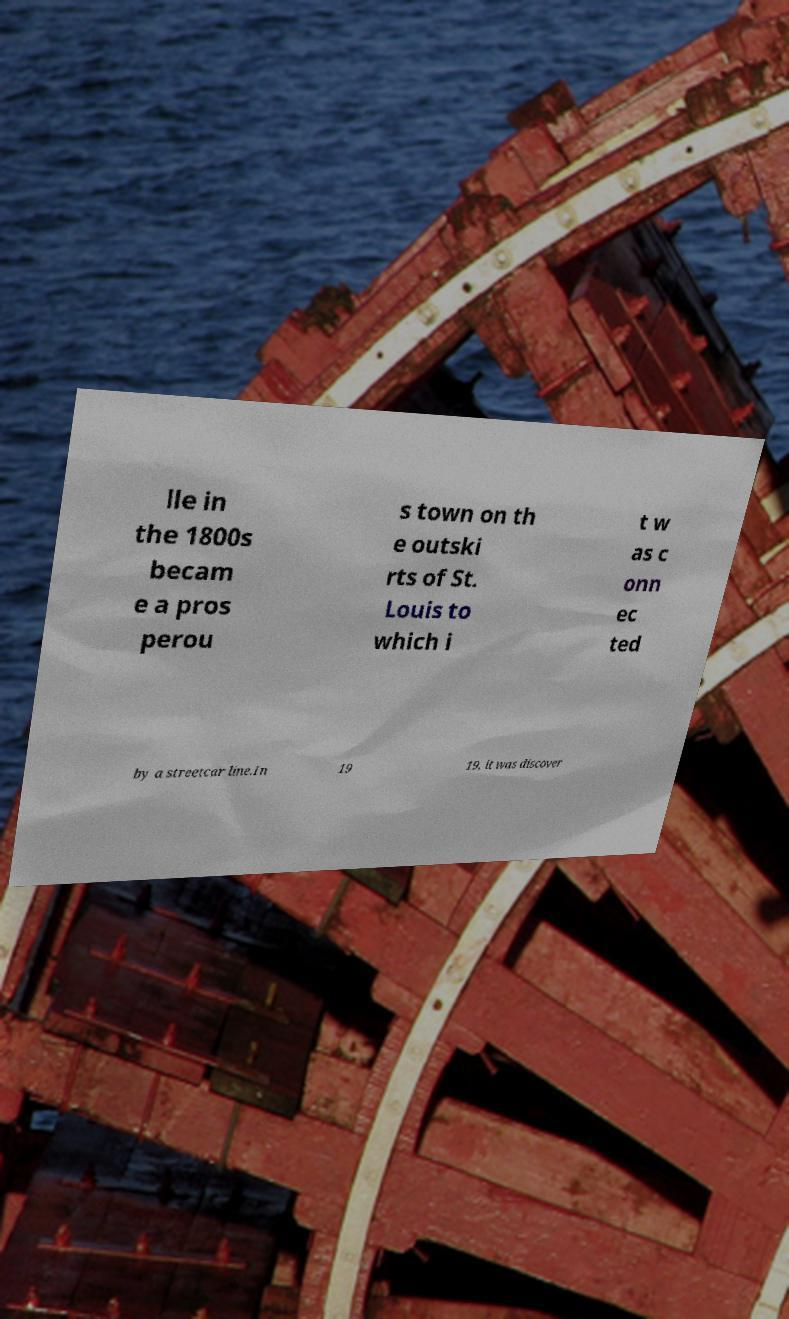Please read and relay the text visible in this image. What does it say? lle in the 1800s becam e a pros perou s town on th e outski rts of St. Louis to which i t w as c onn ec ted by a streetcar line.In 19 19, it was discover 